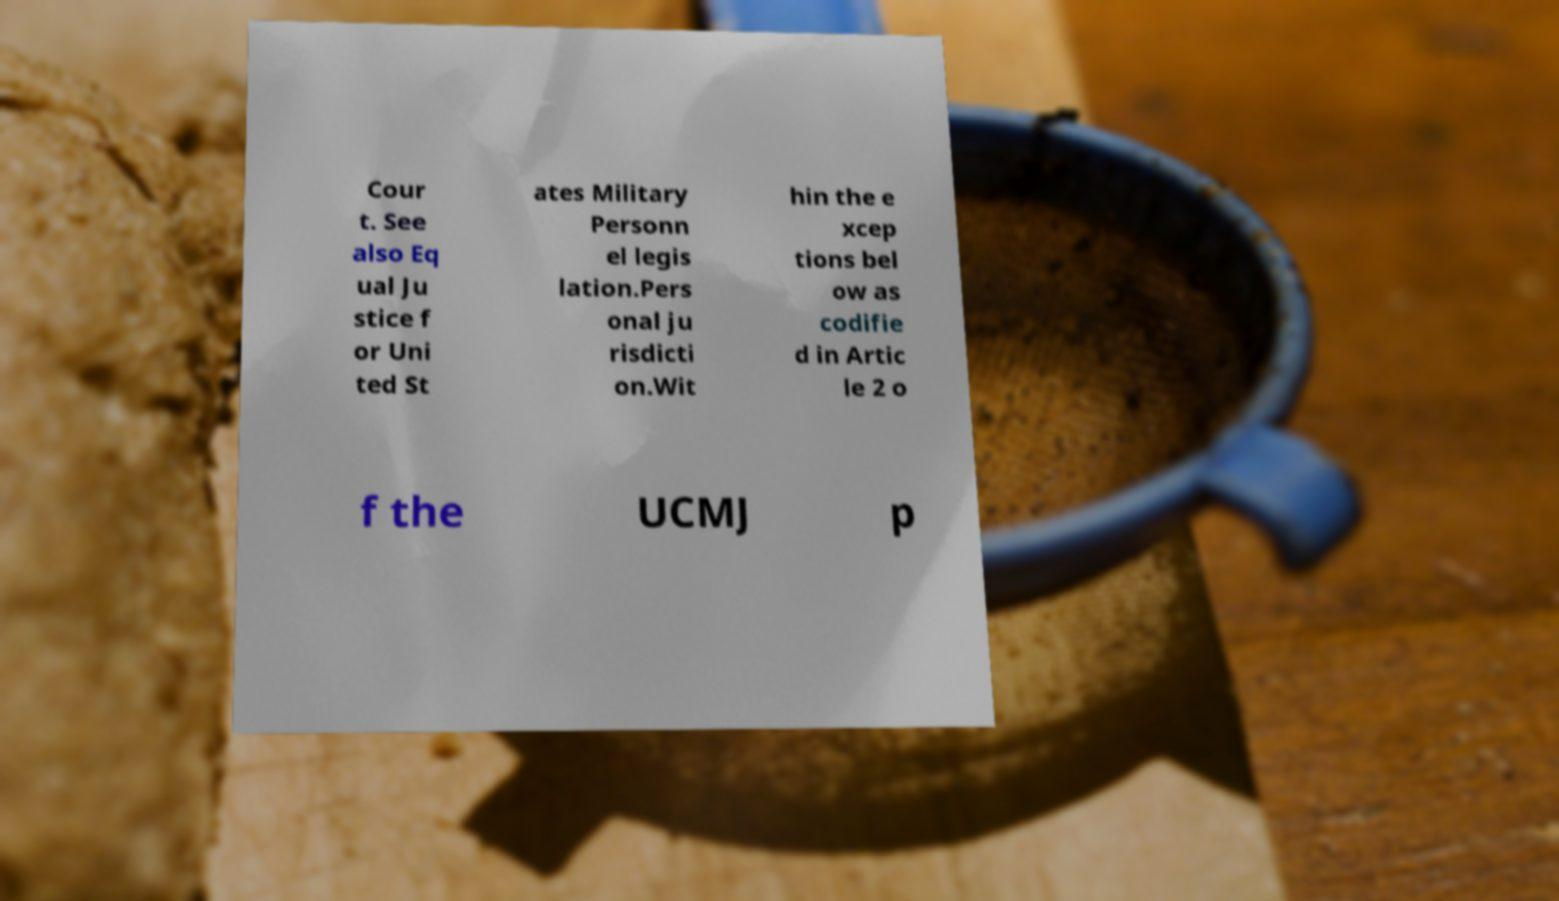Please read and relay the text visible in this image. What does it say? Cour t. See also Eq ual Ju stice f or Uni ted St ates Military Personn el legis lation.Pers onal ju risdicti on.Wit hin the e xcep tions bel ow as codifie d in Artic le 2 o f the UCMJ p 